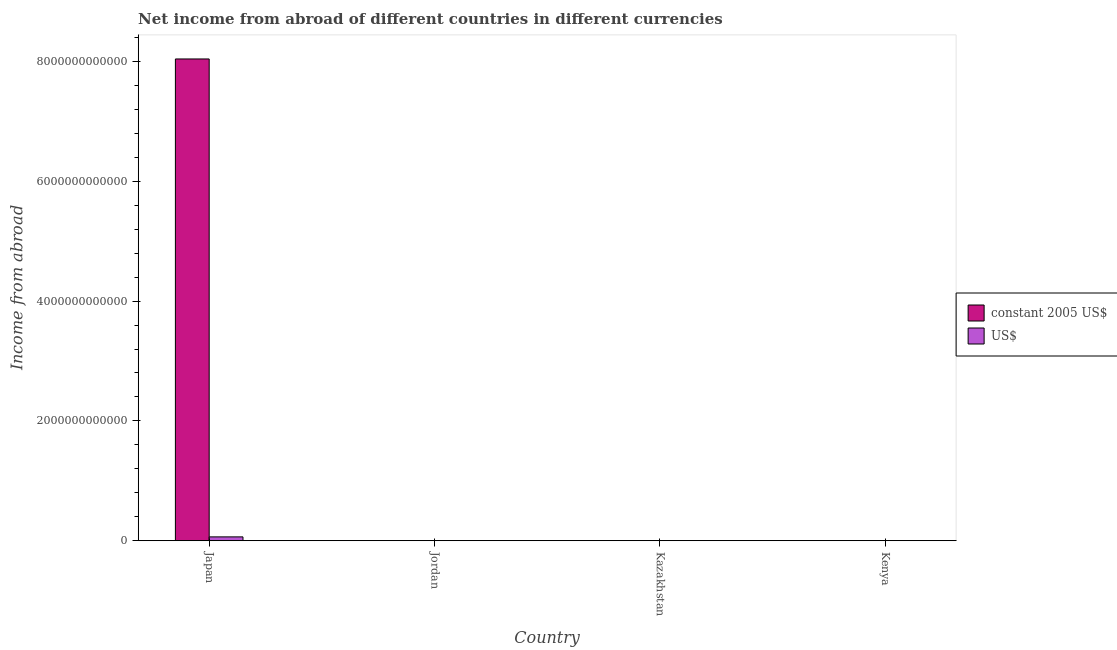Are the number of bars per tick equal to the number of legend labels?
Your response must be concise. No. How many bars are there on the 3rd tick from the left?
Offer a very short reply. 0. What is the label of the 1st group of bars from the left?
Your answer should be compact. Japan. In how many cases, is the number of bars for a given country not equal to the number of legend labels?
Keep it short and to the point. 2. What is the income from abroad in us$ in Kazakhstan?
Offer a very short reply. 0. Across all countries, what is the maximum income from abroad in constant 2005 us$?
Your answer should be very brief. 8.04e+12. In which country was the income from abroad in constant 2005 us$ maximum?
Keep it short and to the point. Japan. What is the total income from abroad in us$ in the graph?
Offer a terse response. 6.42e+1. What is the difference between the income from abroad in us$ in Japan and that in Jordan?
Provide a succinct answer. 6.41e+1. What is the difference between the income from abroad in constant 2005 us$ in Kazakhstan and the income from abroad in us$ in Jordan?
Offer a very short reply. -7.71e+07. What is the average income from abroad in constant 2005 us$ per country?
Offer a terse response. 2.01e+12. What is the difference between the income from abroad in constant 2005 us$ and income from abroad in us$ in Japan?
Your answer should be compact. 7.98e+12. What is the ratio of the income from abroad in us$ in Japan to that in Jordan?
Provide a succinct answer. 831.89. What is the difference between the highest and the lowest income from abroad in us$?
Offer a terse response. 6.41e+1. In how many countries, is the income from abroad in constant 2005 us$ greater than the average income from abroad in constant 2005 us$ taken over all countries?
Offer a very short reply. 1. How many bars are there?
Ensure brevity in your answer.  4. How many countries are there in the graph?
Give a very brief answer. 4. What is the difference between two consecutive major ticks on the Y-axis?
Your response must be concise. 2.00e+12. Does the graph contain any zero values?
Your answer should be very brief. Yes. How are the legend labels stacked?
Ensure brevity in your answer.  Vertical. What is the title of the graph?
Provide a short and direct response. Net income from abroad of different countries in different currencies. What is the label or title of the Y-axis?
Make the answer very short. Income from abroad. What is the Income from abroad of constant 2005 US$ in Japan?
Your answer should be very brief. 8.04e+12. What is the Income from abroad in US$ in Japan?
Your response must be concise. 6.41e+1. What is the Income from abroad of constant 2005 US$ in Jordan?
Ensure brevity in your answer.  5.47e+07. What is the Income from abroad in US$ in Jordan?
Your response must be concise. 7.71e+07. What is the Income from abroad in constant 2005 US$ in Kazakhstan?
Your answer should be very brief. 0. Across all countries, what is the maximum Income from abroad in constant 2005 US$?
Give a very brief answer. 8.04e+12. Across all countries, what is the maximum Income from abroad in US$?
Keep it short and to the point. 6.41e+1. Across all countries, what is the minimum Income from abroad in constant 2005 US$?
Ensure brevity in your answer.  0. Across all countries, what is the minimum Income from abroad of US$?
Provide a succinct answer. 0. What is the total Income from abroad in constant 2005 US$ in the graph?
Your answer should be compact. 8.04e+12. What is the total Income from abroad of US$ in the graph?
Your answer should be very brief. 6.42e+1. What is the difference between the Income from abroad in constant 2005 US$ in Japan and that in Jordan?
Keep it short and to the point. 8.04e+12. What is the difference between the Income from abroad in US$ in Japan and that in Jordan?
Give a very brief answer. 6.41e+1. What is the difference between the Income from abroad in constant 2005 US$ in Japan and the Income from abroad in US$ in Jordan?
Give a very brief answer. 8.04e+12. What is the average Income from abroad in constant 2005 US$ per country?
Your response must be concise. 2.01e+12. What is the average Income from abroad in US$ per country?
Offer a very short reply. 1.61e+1. What is the difference between the Income from abroad of constant 2005 US$ and Income from abroad of US$ in Japan?
Ensure brevity in your answer.  7.98e+12. What is the difference between the Income from abroad of constant 2005 US$ and Income from abroad of US$ in Jordan?
Offer a very short reply. -2.24e+07. What is the ratio of the Income from abroad in constant 2005 US$ in Japan to that in Jordan?
Provide a short and direct response. 1.47e+05. What is the ratio of the Income from abroad of US$ in Japan to that in Jordan?
Give a very brief answer. 831.89. What is the difference between the highest and the lowest Income from abroad in constant 2005 US$?
Your answer should be compact. 8.04e+12. What is the difference between the highest and the lowest Income from abroad of US$?
Your answer should be very brief. 6.41e+1. 